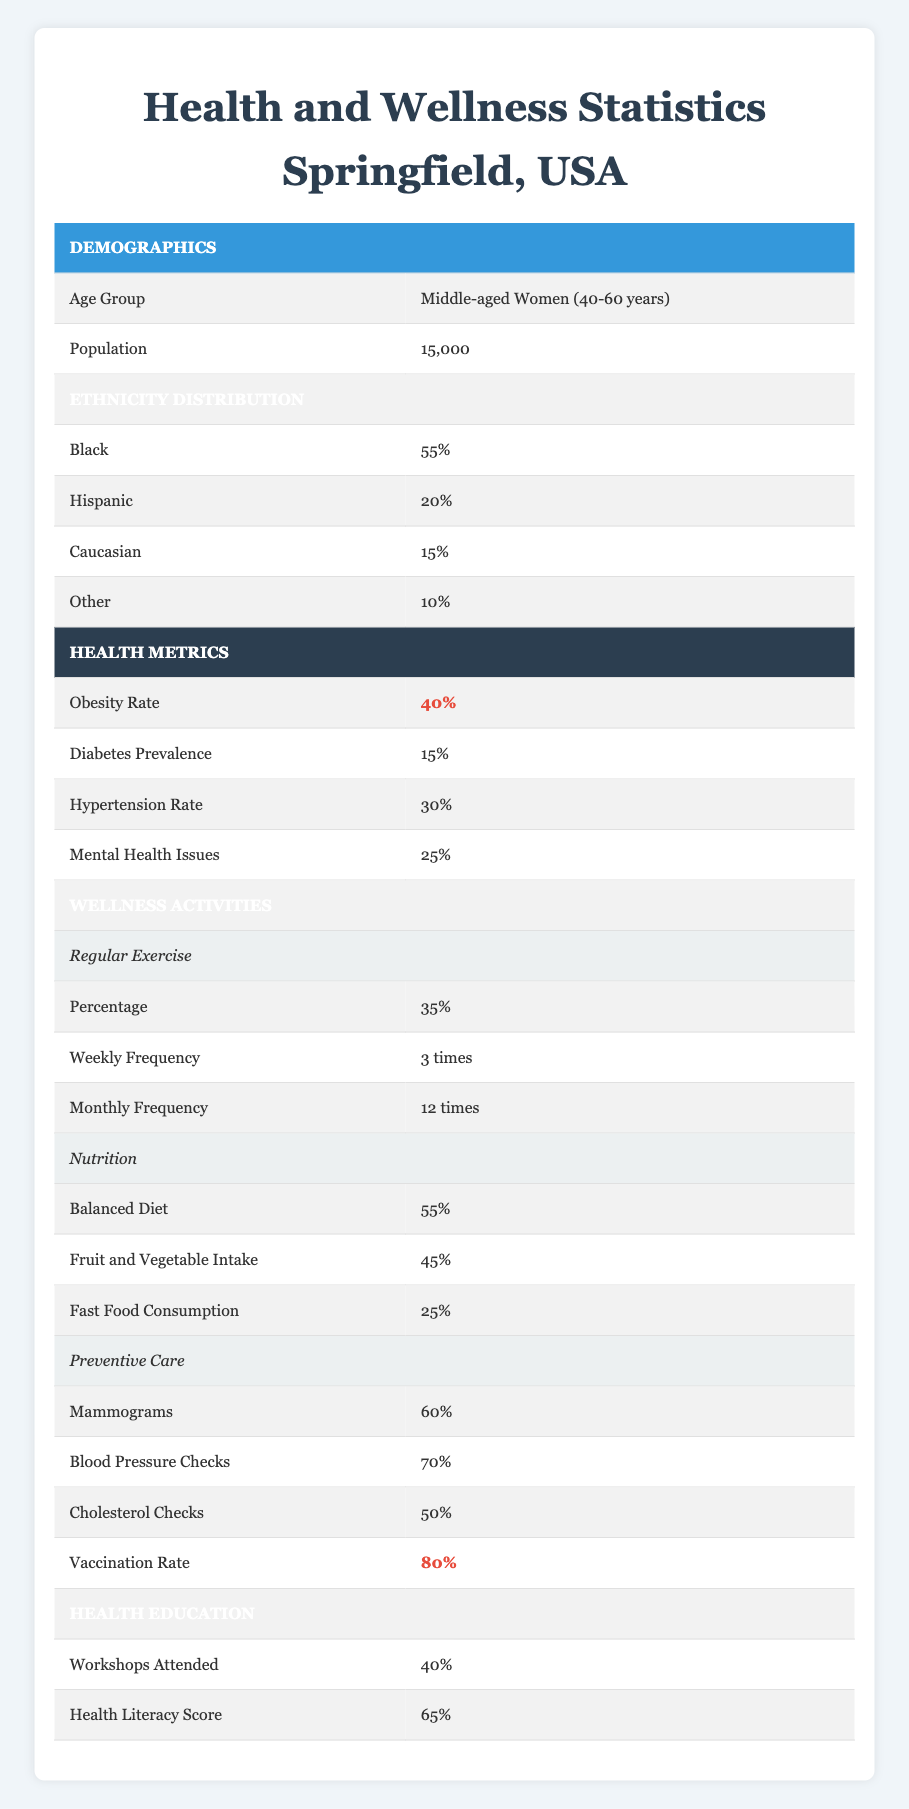What is the obesity rate for middle-aged women in Springfield? The table shows that the obesity rate for middle-aged women is listed under the Health Metrics section. It states that the obesity rate is 40%.
Answer: 40% What percentage of middle-aged women in Springfield attend health workshops? In the Health Education section, it specifies that 40% of middle-aged women attend workshops.
Answer: 40% Is the vaccination rate higher than the mammogram rate in Springfield? The table lists the vaccination rate as 80% and the mammogram rate as 60%. Since 80% is greater than 60%, the answer is yes.
Answer: Yes What percentage of middle-aged women in Springfield follow a balanced diet? Looking at the Nutrition section, it states that 55% of middle-aged women report having a balanced diet.
Answer: 55% What is the difference between the percentage of women who routinely get blood pressure checks and those who have cholesterol checks? The blood pressure checks are at 70% and cholesterol checks are at 50%. The difference is calculated as 70% - 50% = 20%.
Answer: 20% How many preventive care checks have a participation rate of 60% or higher? From the Preventive Care section, mammograms (60%), blood pressure checks (70%), and vaccination rate (80%) are above 60%. This totals three checks meeting the criteria.
Answer: 3 What is the average percentage of women participating in regular exercise compared to those with mental health issues? Regular exercise is 35% and mental health issues are at 25%. To find the average: (35% + 25%) / 2 = 30%.
Answer: 30% Do more middle-aged women consume fast food than intake fruits and vegetables? Fast food consumption is at 25% and fruit and vegetable intake at 45%. Since 25% is less than 45%, more women consume fruits and vegetables.
Answer: No What percentage of middle-aged women in Springfield have diabetes? The diabetes prevalence is specifically mentioned in the Health Metrics section as 15%.
Answer: 15% 